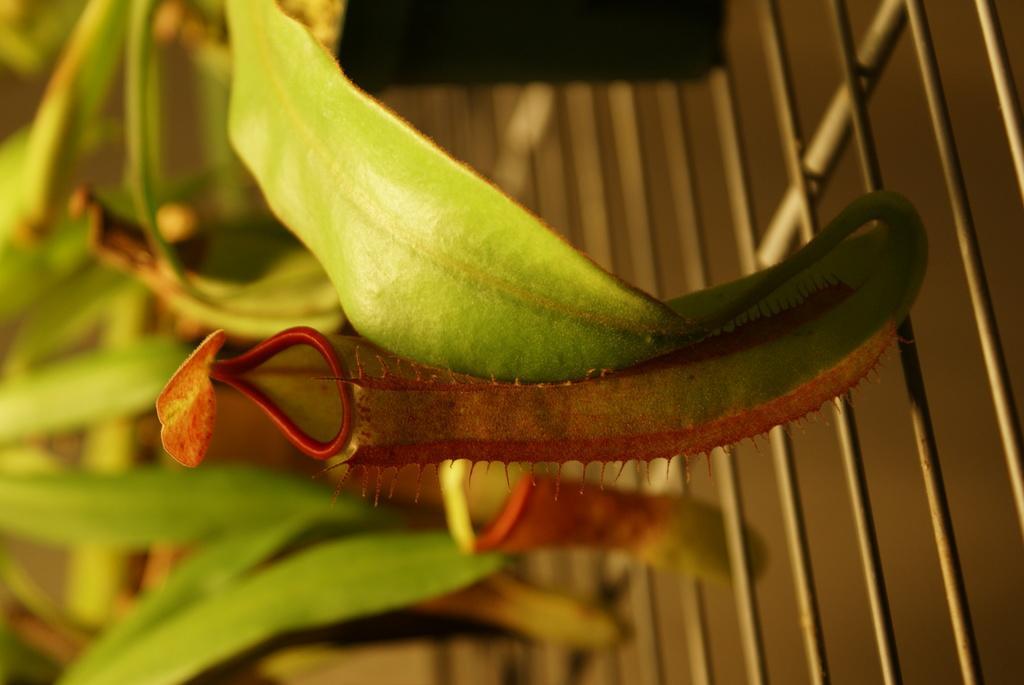Could you give a brief overview of what you see in this image? In this image I see the green leaves and I see the grill over here and I see that it is blurred in the background. 